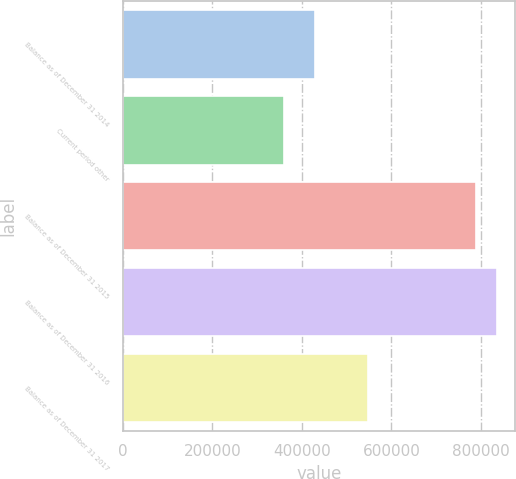Convert chart. <chart><loc_0><loc_0><loc_500><loc_500><bar_chart><fcel>Balance as of December 31 2014<fcel>Current period other<fcel>Balance as of December 31 2015<fcel>Balance as of December 31 2016<fcel>Balance as of December 31 2017<nl><fcel>428505<fcel>360147<fcel>788652<fcel>835173<fcel>547927<nl></chart> 